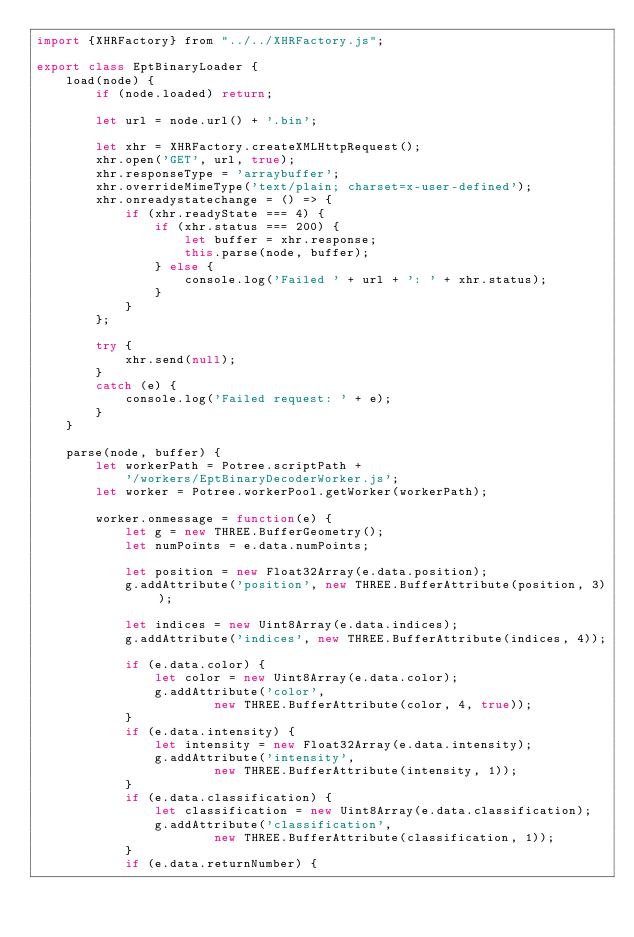<code> <loc_0><loc_0><loc_500><loc_500><_JavaScript_>import {XHRFactory} from "../../XHRFactory.js";

export class EptBinaryLoader {
	load(node) {
		if (node.loaded) return;

		let url = node.url() + '.bin';

		let xhr = XHRFactory.createXMLHttpRequest();
		xhr.open('GET', url, true);
		xhr.responseType = 'arraybuffer';
		xhr.overrideMimeType('text/plain; charset=x-user-defined');
		xhr.onreadystatechange = () => {
			if (xhr.readyState === 4) {
				if (xhr.status === 200) {
					let buffer = xhr.response;
					this.parse(node, buffer);
				} else {
					console.log('Failed ' + url + ': ' + xhr.status);
				}
			}
		};

		try {
			xhr.send(null);
		}
		catch (e) {
			console.log('Failed request: ' + e);
		}
	}

	parse(node, buffer) {
		let workerPath = Potree.scriptPath +
			'/workers/EptBinaryDecoderWorker.js';
		let worker = Potree.workerPool.getWorker(workerPath);

		worker.onmessage = function(e) {
			let g = new THREE.BufferGeometry();
			let numPoints = e.data.numPoints;

			let position = new Float32Array(e.data.position);
			g.addAttribute('position', new THREE.BufferAttribute(position, 3));

			let indices = new Uint8Array(e.data.indices);
			g.addAttribute('indices', new THREE.BufferAttribute(indices, 4));

			if (e.data.color) {
				let color = new Uint8Array(e.data.color);
				g.addAttribute('color',
						new THREE.BufferAttribute(color, 4, true));
			}
			if (e.data.intensity) {
				let intensity = new Float32Array(e.data.intensity);
				g.addAttribute('intensity',
						new THREE.BufferAttribute(intensity, 1));
			}
			if (e.data.classification) {
				let classification = new Uint8Array(e.data.classification);
				g.addAttribute('classification',
						new THREE.BufferAttribute(classification, 1));
			}
			if (e.data.returnNumber) {</code> 